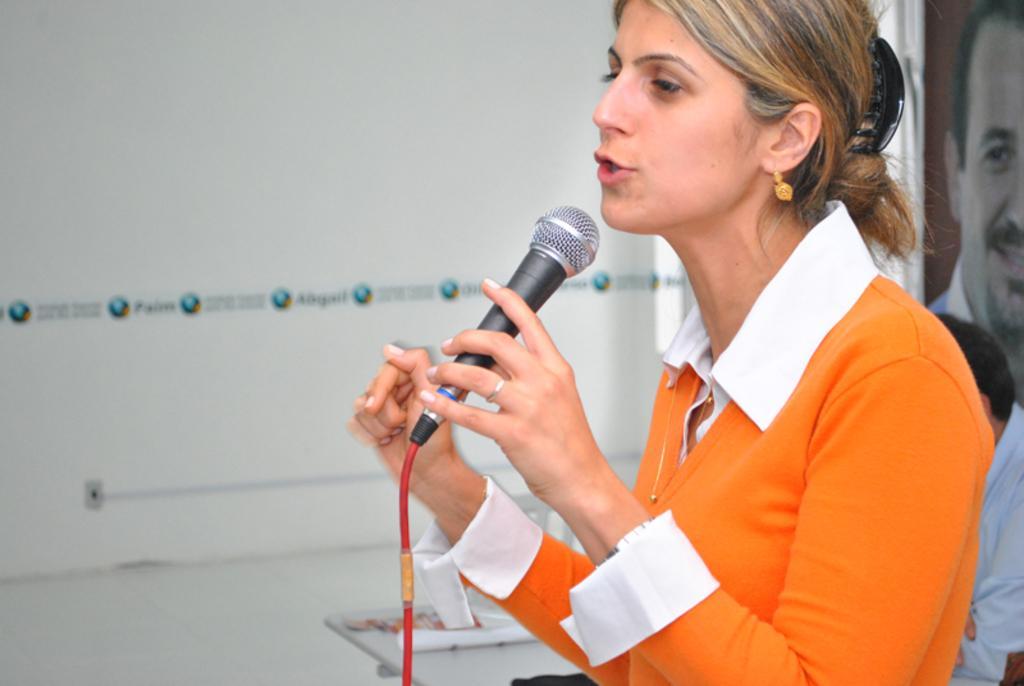How would you summarize this image in a sentence or two? In this image there is a woman, she is wearing white and orange color shirt, holding a mic in her hand, behind her there is a man sitting on chair, in front of him there is a table, behind that man and there is a picture of a man, in the background there is a wall. 